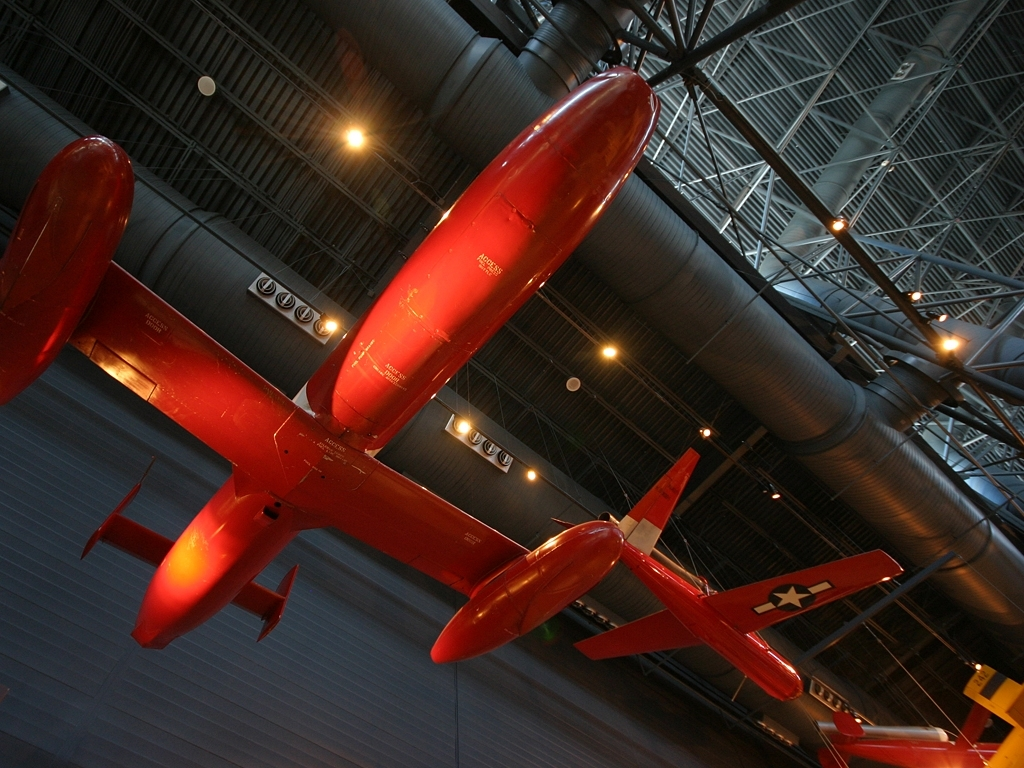Can you tell me more about the aircraft in the foreground? Certainly! The aircraft in the foreground is red with a slim, elongated fuselage and twin boom tails. This design suggests it's built for speed and agility, likely a racing plane or perhaps a reconnaissance aircraft. The sleek aerodynamic shape indicates it's designed to reduce drag and perform at high speeds. What can one learn from the museum context of the image? A museum setting often means that the aircraft played a significant role in aviation history, whether it be through technological innovation, historical significance, or outstanding performance. It provides an educational setting for visitors to learn about the aircraft's design, function, and the era it comes from. 